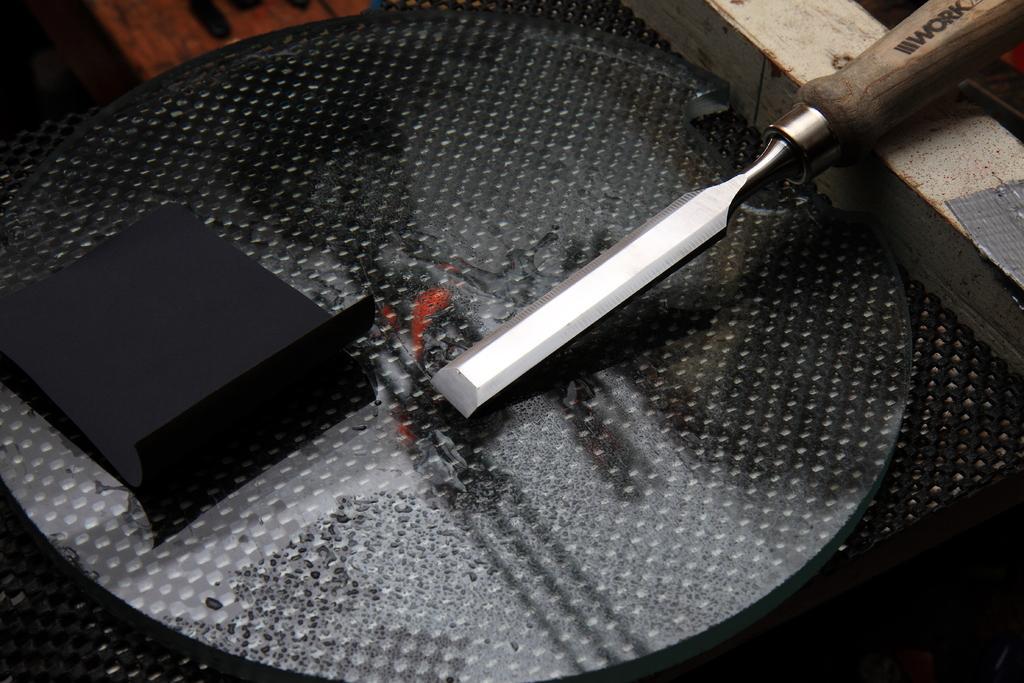Describe this image in one or two sentences. I think this is the chisel tool, which is used in wood carving. This is a paper, which is black in color. I can see a wooden block. This looks like a glass, which is placed on the black table. 